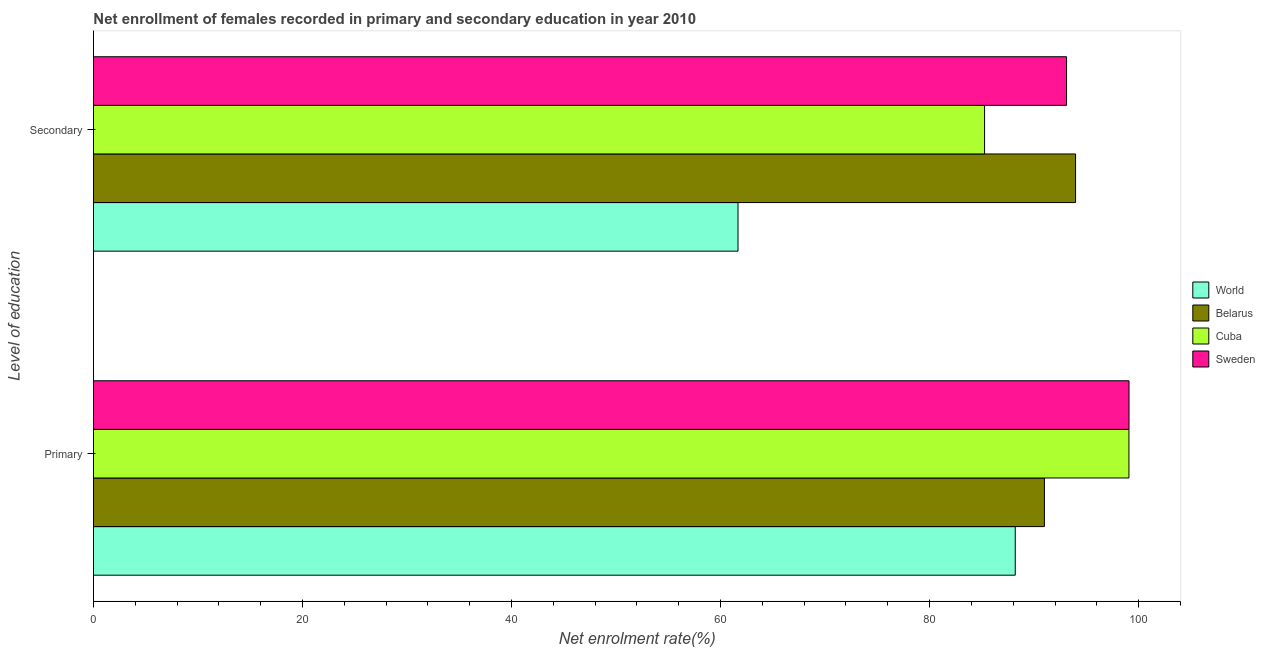Are the number of bars on each tick of the Y-axis equal?
Ensure brevity in your answer.  Yes. How many bars are there on the 1st tick from the top?
Provide a succinct answer. 4. What is the label of the 1st group of bars from the top?
Offer a terse response. Secondary. What is the enrollment rate in primary education in Belarus?
Make the answer very short. 90.98. Across all countries, what is the maximum enrollment rate in primary education?
Provide a succinct answer. 99.08. Across all countries, what is the minimum enrollment rate in primary education?
Make the answer very short. 88.19. In which country was the enrollment rate in secondary education maximum?
Give a very brief answer. Belarus. In which country was the enrollment rate in secondary education minimum?
Make the answer very short. World. What is the total enrollment rate in secondary education in the graph?
Keep it short and to the point. 334. What is the difference between the enrollment rate in primary education in Cuba and that in World?
Your answer should be compact. 10.88. What is the difference between the enrollment rate in secondary education in World and the enrollment rate in primary education in Belarus?
Provide a succinct answer. -29.31. What is the average enrollment rate in secondary education per country?
Provide a short and direct response. 83.5. What is the difference between the enrollment rate in primary education and enrollment rate in secondary education in Cuba?
Ensure brevity in your answer.  13.81. In how many countries, is the enrollment rate in primary education greater than 40 %?
Make the answer very short. 4. What is the ratio of the enrollment rate in secondary education in Sweden to that in Belarus?
Ensure brevity in your answer.  0.99. Is the enrollment rate in secondary education in World less than that in Cuba?
Provide a succinct answer. Yes. In how many countries, is the enrollment rate in secondary education greater than the average enrollment rate in secondary education taken over all countries?
Offer a very short reply. 3. What does the 3rd bar from the top in Primary represents?
Offer a terse response. Belarus. What does the 1st bar from the bottom in Secondary represents?
Offer a very short reply. World. Are all the bars in the graph horizontal?
Provide a short and direct response. Yes. What is the difference between two consecutive major ticks on the X-axis?
Keep it short and to the point. 20. Are the values on the major ticks of X-axis written in scientific E-notation?
Your answer should be very brief. No. Does the graph contain grids?
Provide a short and direct response. No. Where does the legend appear in the graph?
Offer a terse response. Center right. How many legend labels are there?
Provide a short and direct response. 4. What is the title of the graph?
Offer a very short reply. Net enrollment of females recorded in primary and secondary education in year 2010. Does "Tajikistan" appear as one of the legend labels in the graph?
Provide a succinct answer. No. What is the label or title of the X-axis?
Provide a short and direct response. Net enrolment rate(%). What is the label or title of the Y-axis?
Give a very brief answer. Level of education. What is the Net enrolment rate(%) in World in Primary?
Ensure brevity in your answer.  88.19. What is the Net enrolment rate(%) in Belarus in Primary?
Provide a succinct answer. 90.98. What is the Net enrolment rate(%) in Cuba in Primary?
Your answer should be very brief. 99.07. What is the Net enrolment rate(%) in Sweden in Primary?
Provide a short and direct response. 99.08. What is the Net enrolment rate(%) of World in Secondary?
Ensure brevity in your answer.  61.67. What is the Net enrolment rate(%) in Belarus in Secondary?
Give a very brief answer. 93.97. What is the Net enrolment rate(%) in Cuba in Secondary?
Provide a short and direct response. 85.26. What is the Net enrolment rate(%) of Sweden in Secondary?
Give a very brief answer. 93.1. Across all Level of education, what is the maximum Net enrolment rate(%) of World?
Offer a terse response. 88.19. Across all Level of education, what is the maximum Net enrolment rate(%) of Belarus?
Your answer should be compact. 93.97. Across all Level of education, what is the maximum Net enrolment rate(%) of Cuba?
Give a very brief answer. 99.07. Across all Level of education, what is the maximum Net enrolment rate(%) in Sweden?
Keep it short and to the point. 99.08. Across all Level of education, what is the minimum Net enrolment rate(%) of World?
Offer a terse response. 61.67. Across all Level of education, what is the minimum Net enrolment rate(%) in Belarus?
Your answer should be very brief. 90.98. Across all Level of education, what is the minimum Net enrolment rate(%) in Cuba?
Give a very brief answer. 85.26. Across all Level of education, what is the minimum Net enrolment rate(%) in Sweden?
Provide a succinct answer. 93.1. What is the total Net enrolment rate(%) in World in the graph?
Offer a terse response. 149.86. What is the total Net enrolment rate(%) in Belarus in the graph?
Offer a very short reply. 184.95. What is the total Net enrolment rate(%) in Cuba in the graph?
Offer a terse response. 184.33. What is the total Net enrolment rate(%) of Sweden in the graph?
Give a very brief answer. 192.18. What is the difference between the Net enrolment rate(%) in World in Primary and that in Secondary?
Give a very brief answer. 26.53. What is the difference between the Net enrolment rate(%) of Belarus in Primary and that in Secondary?
Ensure brevity in your answer.  -2.98. What is the difference between the Net enrolment rate(%) of Cuba in Primary and that in Secondary?
Give a very brief answer. 13.81. What is the difference between the Net enrolment rate(%) of Sweden in Primary and that in Secondary?
Offer a very short reply. 5.98. What is the difference between the Net enrolment rate(%) of World in Primary and the Net enrolment rate(%) of Belarus in Secondary?
Your answer should be very brief. -5.77. What is the difference between the Net enrolment rate(%) of World in Primary and the Net enrolment rate(%) of Cuba in Secondary?
Keep it short and to the point. 2.93. What is the difference between the Net enrolment rate(%) of World in Primary and the Net enrolment rate(%) of Sweden in Secondary?
Keep it short and to the point. -4.91. What is the difference between the Net enrolment rate(%) of Belarus in Primary and the Net enrolment rate(%) of Cuba in Secondary?
Provide a succinct answer. 5.72. What is the difference between the Net enrolment rate(%) in Belarus in Primary and the Net enrolment rate(%) in Sweden in Secondary?
Offer a very short reply. -2.12. What is the difference between the Net enrolment rate(%) in Cuba in Primary and the Net enrolment rate(%) in Sweden in Secondary?
Your answer should be compact. 5.97. What is the average Net enrolment rate(%) in World per Level of education?
Your answer should be compact. 74.93. What is the average Net enrolment rate(%) of Belarus per Level of education?
Your answer should be compact. 92.47. What is the average Net enrolment rate(%) of Cuba per Level of education?
Keep it short and to the point. 92.17. What is the average Net enrolment rate(%) of Sweden per Level of education?
Provide a short and direct response. 96.09. What is the difference between the Net enrolment rate(%) in World and Net enrolment rate(%) in Belarus in Primary?
Give a very brief answer. -2.79. What is the difference between the Net enrolment rate(%) of World and Net enrolment rate(%) of Cuba in Primary?
Keep it short and to the point. -10.88. What is the difference between the Net enrolment rate(%) in World and Net enrolment rate(%) in Sweden in Primary?
Your answer should be compact. -10.88. What is the difference between the Net enrolment rate(%) in Belarus and Net enrolment rate(%) in Cuba in Primary?
Give a very brief answer. -8.09. What is the difference between the Net enrolment rate(%) in Belarus and Net enrolment rate(%) in Sweden in Primary?
Ensure brevity in your answer.  -8.1. What is the difference between the Net enrolment rate(%) of Cuba and Net enrolment rate(%) of Sweden in Primary?
Offer a very short reply. -0.01. What is the difference between the Net enrolment rate(%) of World and Net enrolment rate(%) of Belarus in Secondary?
Your response must be concise. -32.3. What is the difference between the Net enrolment rate(%) in World and Net enrolment rate(%) in Cuba in Secondary?
Your answer should be compact. -23.59. What is the difference between the Net enrolment rate(%) of World and Net enrolment rate(%) of Sweden in Secondary?
Your response must be concise. -31.43. What is the difference between the Net enrolment rate(%) in Belarus and Net enrolment rate(%) in Cuba in Secondary?
Offer a terse response. 8.71. What is the difference between the Net enrolment rate(%) in Belarus and Net enrolment rate(%) in Sweden in Secondary?
Your answer should be very brief. 0.86. What is the difference between the Net enrolment rate(%) of Cuba and Net enrolment rate(%) of Sweden in Secondary?
Provide a succinct answer. -7.84. What is the ratio of the Net enrolment rate(%) of World in Primary to that in Secondary?
Offer a terse response. 1.43. What is the ratio of the Net enrolment rate(%) in Belarus in Primary to that in Secondary?
Your answer should be very brief. 0.97. What is the ratio of the Net enrolment rate(%) in Cuba in Primary to that in Secondary?
Offer a very short reply. 1.16. What is the ratio of the Net enrolment rate(%) of Sweden in Primary to that in Secondary?
Provide a succinct answer. 1.06. What is the difference between the highest and the second highest Net enrolment rate(%) in World?
Ensure brevity in your answer.  26.53. What is the difference between the highest and the second highest Net enrolment rate(%) in Belarus?
Ensure brevity in your answer.  2.98. What is the difference between the highest and the second highest Net enrolment rate(%) in Cuba?
Offer a terse response. 13.81. What is the difference between the highest and the second highest Net enrolment rate(%) of Sweden?
Ensure brevity in your answer.  5.98. What is the difference between the highest and the lowest Net enrolment rate(%) in World?
Make the answer very short. 26.53. What is the difference between the highest and the lowest Net enrolment rate(%) of Belarus?
Give a very brief answer. 2.98. What is the difference between the highest and the lowest Net enrolment rate(%) in Cuba?
Offer a very short reply. 13.81. What is the difference between the highest and the lowest Net enrolment rate(%) in Sweden?
Provide a succinct answer. 5.98. 